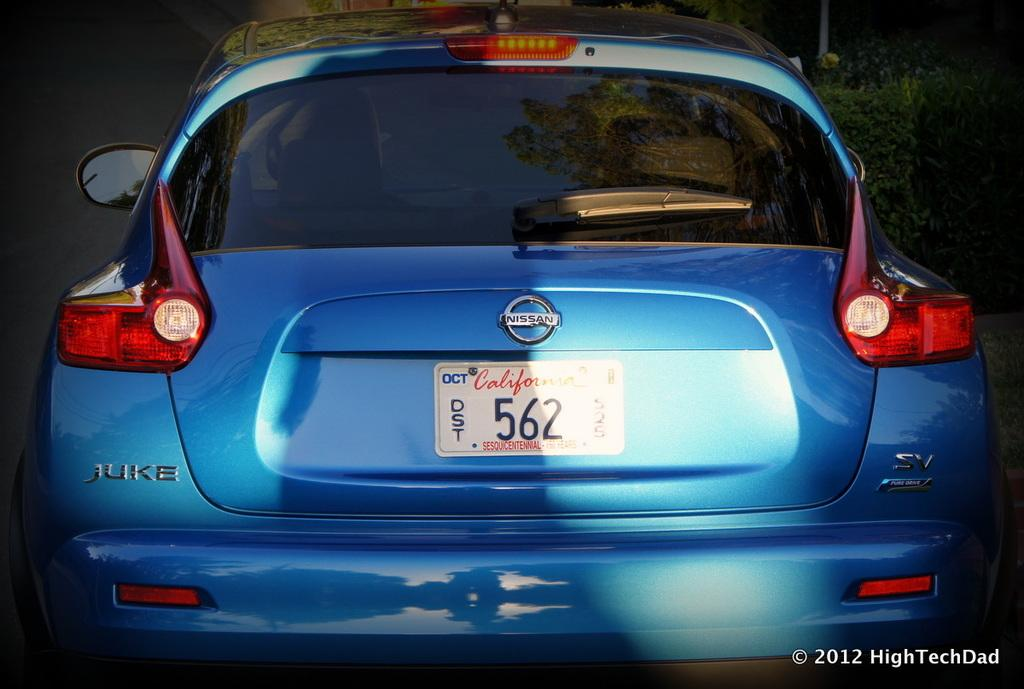Provide a one-sentence caption for the provided image. The blue Nissan Juke is from the state of California. 